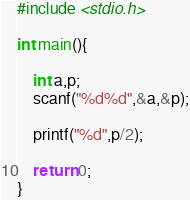Convert code to text. <code><loc_0><loc_0><loc_500><loc_500><_C_>#include <stdio.h>

int main(){
	
	int a,p;
	scanf("%d%d",&a,&p);

	printf("%d",p/2);

	return 0;
}</code> 